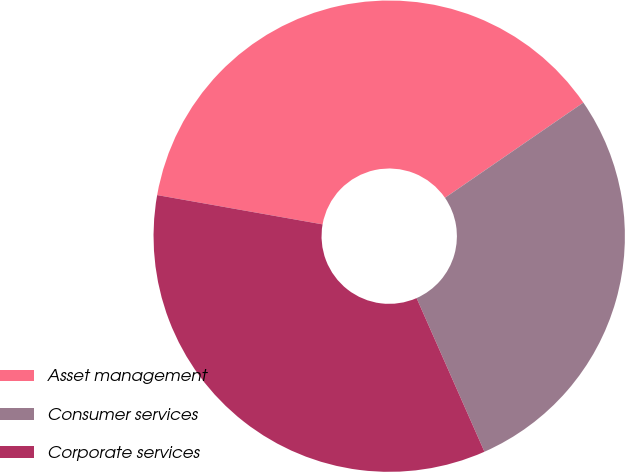<chart> <loc_0><loc_0><loc_500><loc_500><pie_chart><fcel>Asset management<fcel>Consumer services<fcel>Corporate services<nl><fcel>37.62%<fcel>27.97%<fcel>34.41%<nl></chart> 